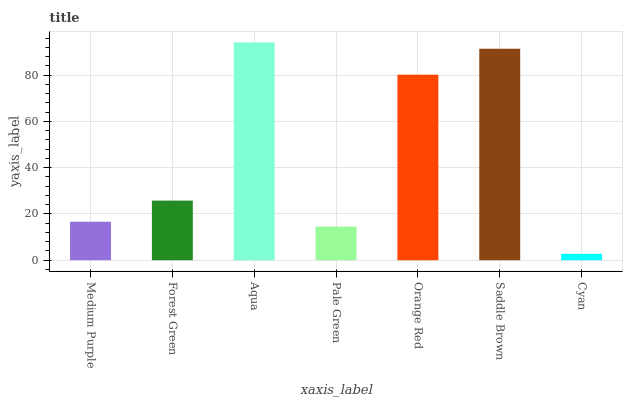Is Cyan the minimum?
Answer yes or no. Yes. Is Aqua the maximum?
Answer yes or no. Yes. Is Forest Green the minimum?
Answer yes or no. No. Is Forest Green the maximum?
Answer yes or no. No. Is Forest Green greater than Medium Purple?
Answer yes or no. Yes. Is Medium Purple less than Forest Green?
Answer yes or no. Yes. Is Medium Purple greater than Forest Green?
Answer yes or no. No. Is Forest Green less than Medium Purple?
Answer yes or no. No. Is Forest Green the high median?
Answer yes or no. Yes. Is Forest Green the low median?
Answer yes or no. Yes. Is Medium Purple the high median?
Answer yes or no. No. Is Cyan the low median?
Answer yes or no. No. 